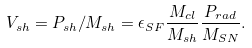<formula> <loc_0><loc_0><loc_500><loc_500>V _ { s h } = P _ { s h } / M _ { s h } = \epsilon _ { S F } \frac { M _ { c l } } { M _ { s h } } \frac { P _ { r a d } } { M _ { S N } } .</formula> 